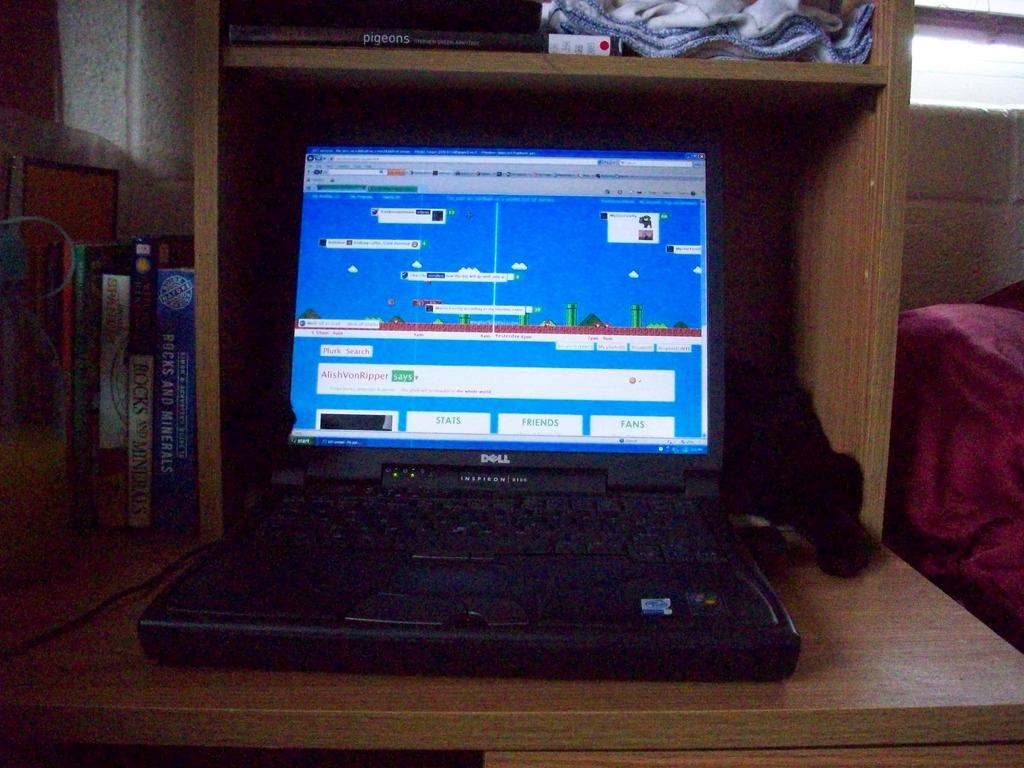Provide a one-sentence caption for the provided image. A black laptop with a display screen that has a box that sayas AlishVonRipper says. 